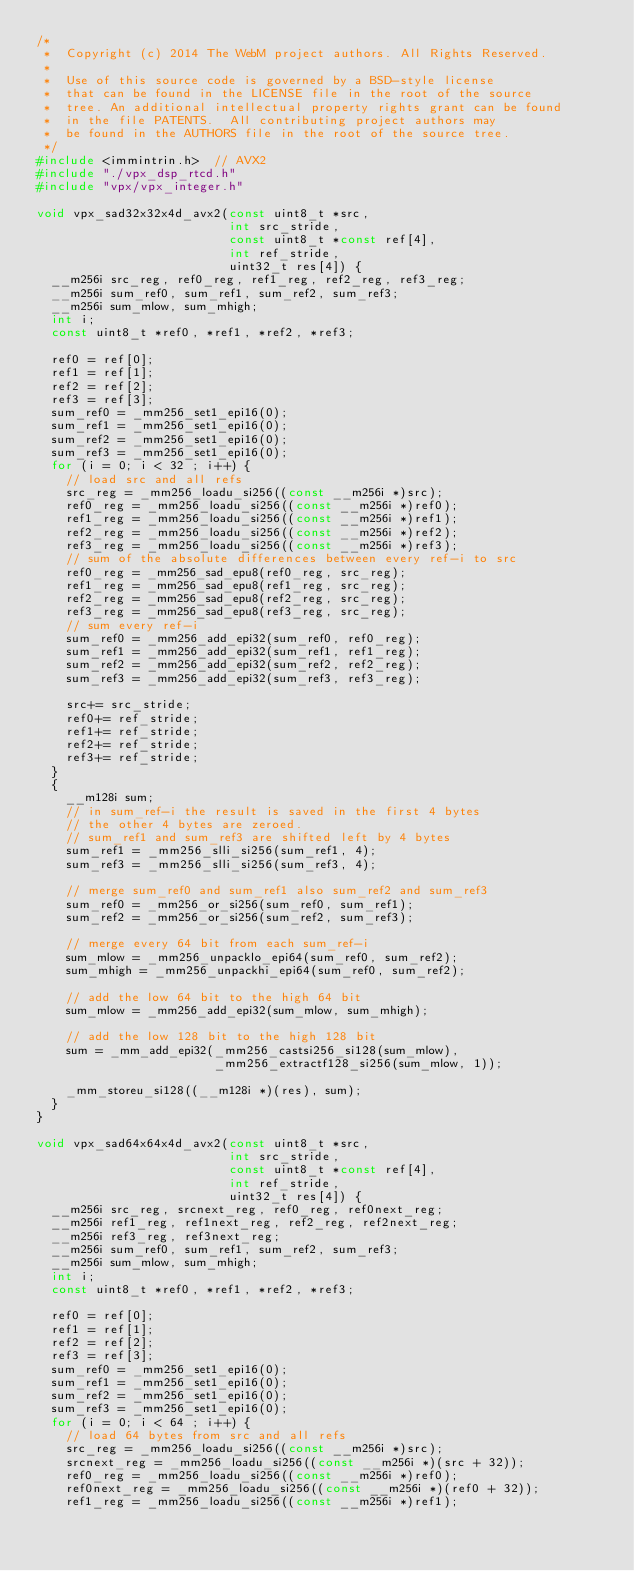Convert code to text. <code><loc_0><loc_0><loc_500><loc_500><_C_>/*
 *  Copyright (c) 2014 The WebM project authors. All Rights Reserved.
 *
 *  Use of this source code is governed by a BSD-style license
 *  that can be found in the LICENSE file in the root of the source
 *  tree. An additional intellectual property rights grant can be found
 *  in the file PATENTS.  All contributing project authors may
 *  be found in the AUTHORS file in the root of the source tree.
 */
#include <immintrin.h>  // AVX2
#include "./vpx_dsp_rtcd.h"
#include "vpx/vpx_integer.h"

void vpx_sad32x32x4d_avx2(const uint8_t *src,
                          int src_stride,
                          const uint8_t *const ref[4],
                          int ref_stride,
                          uint32_t res[4]) {
  __m256i src_reg, ref0_reg, ref1_reg, ref2_reg, ref3_reg;
  __m256i sum_ref0, sum_ref1, sum_ref2, sum_ref3;
  __m256i sum_mlow, sum_mhigh;
  int i;
  const uint8_t *ref0, *ref1, *ref2, *ref3;

  ref0 = ref[0];
  ref1 = ref[1];
  ref2 = ref[2];
  ref3 = ref[3];
  sum_ref0 = _mm256_set1_epi16(0);
  sum_ref1 = _mm256_set1_epi16(0);
  sum_ref2 = _mm256_set1_epi16(0);
  sum_ref3 = _mm256_set1_epi16(0);
  for (i = 0; i < 32 ; i++) {
    // load src and all refs
    src_reg = _mm256_loadu_si256((const __m256i *)src);
    ref0_reg = _mm256_loadu_si256((const __m256i *)ref0);
    ref1_reg = _mm256_loadu_si256((const __m256i *)ref1);
    ref2_reg = _mm256_loadu_si256((const __m256i *)ref2);
    ref3_reg = _mm256_loadu_si256((const __m256i *)ref3);
    // sum of the absolute differences between every ref-i to src
    ref0_reg = _mm256_sad_epu8(ref0_reg, src_reg);
    ref1_reg = _mm256_sad_epu8(ref1_reg, src_reg);
    ref2_reg = _mm256_sad_epu8(ref2_reg, src_reg);
    ref3_reg = _mm256_sad_epu8(ref3_reg, src_reg);
    // sum every ref-i
    sum_ref0 = _mm256_add_epi32(sum_ref0, ref0_reg);
    sum_ref1 = _mm256_add_epi32(sum_ref1, ref1_reg);
    sum_ref2 = _mm256_add_epi32(sum_ref2, ref2_reg);
    sum_ref3 = _mm256_add_epi32(sum_ref3, ref3_reg);

    src+= src_stride;
    ref0+= ref_stride;
    ref1+= ref_stride;
    ref2+= ref_stride;
    ref3+= ref_stride;
  }
  {
    __m128i sum;
    // in sum_ref-i the result is saved in the first 4 bytes
    // the other 4 bytes are zeroed.
    // sum_ref1 and sum_ref3 are shifted left by 4 bytes
    sum_ref1 = _mm256_slli_si256(sum_ref1, 4);
    sum_ref3 = _mm256_slli_si256(sum_ref3, 4);

    // merge sum_ref0 and sum_ref1 also sum_ref2 and sum_ref3
    sum_ref0 = _mm256_or_si256(sum_ref0, sum_ref1);
    sum_ref2 = _mm256_or_si256(sum_ref2, sum_ref3);

    // merge every 64 bit from each sum_ref-i
    sum_mlow = _mm256_unpacklo_epi64(sum_ref0, sum_ref2);
    sum_mhigh = _mm256_unpackhi_epi64(sum_ref0, sum_ref2);

    // add the low 64 bit to the high 64 bit
    sum_mlow = _mm256_add_epi32(sum_mlow, sum_mhigh);

    // add the low 128 bit to the high 128 bit
    sum = _mm_add_epi32(_mm256_castsi256_si128(sum_mlow),
                        _mm256_extractf128_si256(sum_mlow, 1));

    _mm_storeu_si128((__m128i *)(res), sum);
  }
}

void vpx_sad64x64x4d_avx2(const uint8_t *src,
                          int src_stride,
                          const uint8_t *const ref[4],
                          int ref_stride,
                          uint32_t res[4]) {
  __m256i src_reg, srcnext_reg, ref0_reg, ref0next_reg;
  __m256i ref1_reg, ref1next_reg, ref2_reg, ref2next_reg;
  __m256i ref3_reg, ref3next_reg;
  __m256i sum_ref0, sum_ref1, sum_ref2, sum_ref3;
  __m256i sum_mlow, sum_mhigh;
  int i;
  const uint8_t *ref0, *ref1, *ref2, *ref3;

  ref0 = ref[0];
  ref1 = ref[1];
  ref2 = ref[2];
  ref3 = ref[3];
  sum_ref0 = _mm256_set1_epi16(0);
  sum_ref1 = _mm256_set1_epi16(0);
  sum_ref2 = _mm256_set1_epi16(0);
  sum_ref3 = _mm256_set1_epi16(0);
  for (i = 0; i < 64 ; i++) {
    // load 64 bytes from src and all refs
    src_reg = _mm256_loadu_si256((const __m256i *)src);
    srcnext_reg = _mm256_loadu_si256((const __m256i *)(src + 32));
    ref0_reg = _mm256_loadu_si256((const __m256i *)ref0);
    ref0next_reg = _mm256_loadu_si256((const __m256i *)(ref0 + 32));
    ref1_reg = _mm256_loadu_si256((const __m256i *)ref1);</code> 